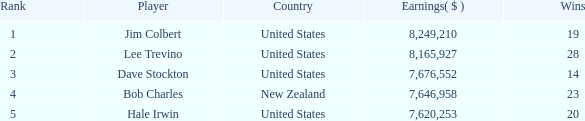What's the mean count of wins for players who are ranked lower than 2 and have earned above $7,676,552? None. 